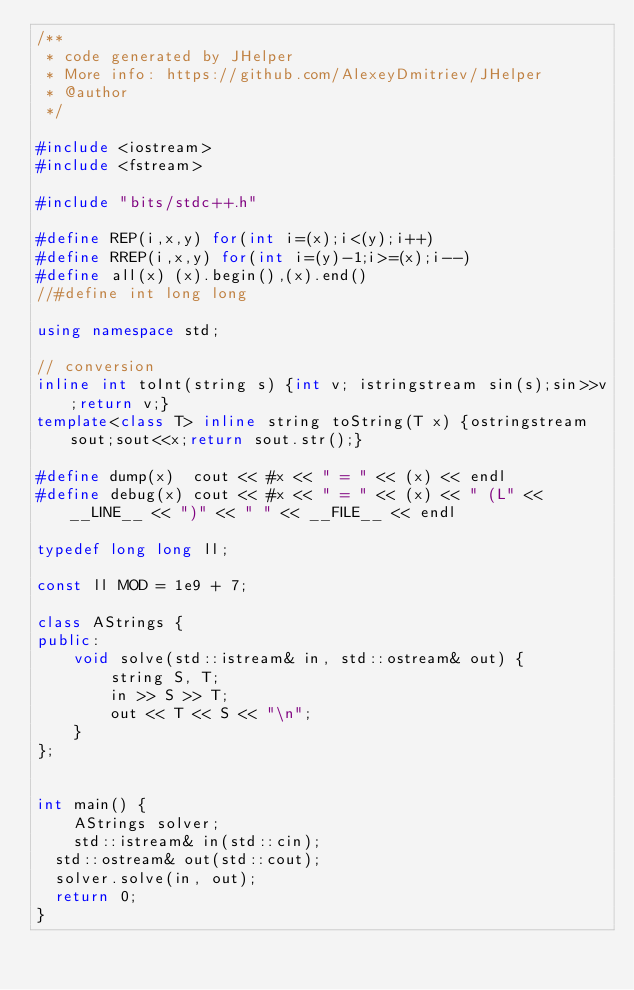<code> <loc_0><loc_0><loc_500><loc_500><_C++_>/**
 * code generated by JHelper
 * More info: https://github.com/AlexeyDmitriev/JHelper
 * @author
 */

#include <iostream>
#include <fstream>

#include "bits/stdc++.h"

#define REP(i,x,y) for(int i=(x);i<(y);i++)
#define RREP(i,x,y) for(int i=(y)-1;i>=(x);i--)
#define all(x) (x).begin(),(x).end()
//#define int long long

using namespace std;

// conversion
inline int toInt(string s) {int v; istringstream sin(s);sin>>v;return v;}
template<class T> inline string toString(T x) {ostringstream sout;sout<<x;return sout.str();}

#define dump(x)  cout << #x << " = " << (x) << endl
#define debug(x) cout << #x << " = " << (x) << " (L" << __LINE__ << ")" << " " << __FILE__ << endl

typedef long long ll;

const ll MOD = 1e9 + 7;

class AStrings {
public:
    void solve(std::istream& in, std::ostream& out) {
        string S, T;
        in >> S >> T;
        out << T << S << "\n";
    }
};


int main() {
    AStrings solver;
    std::istream& in(std::cin);
	std::ostream& out(std::cout);
	solver.solve(in, out);
	return 0;
}
</code> 